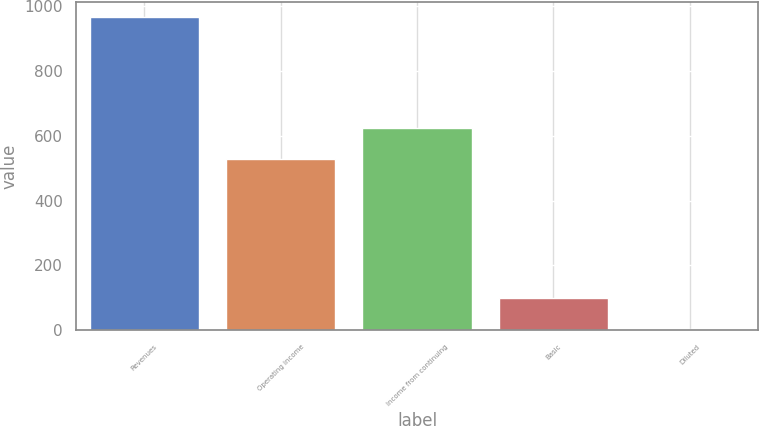Convert chart. <chart><loc_0><loc_0><loc_500><loc_500><bar_chart><fcel>Revenues<fcel>Operating income<fcel>Income from continuing<fcel>Basic<fcel>Diluted<nl><fcel>965<fcel>528<fcel>624.15<fcel>99.64<fcel>3.49<nl></chart> 